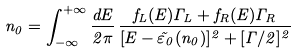<formula> <loc_0><loc_0><loc_500><loc_500>n _ { 0 } = \int _ { - \infty } ^ { + \infty } \frac { d E } { 2 \pi } \, \frac { f _ { L } ( E ) \Gamma _ { L } + f _ { R } ( E ) \Gamma _ { R } } { [ E - \tilde { \varepsilon } _ { 0 } ( n _ { 0 } ) ] ^ { 2 } + [ \Gamma / 2 ] ^ { 2 } }</formula> 